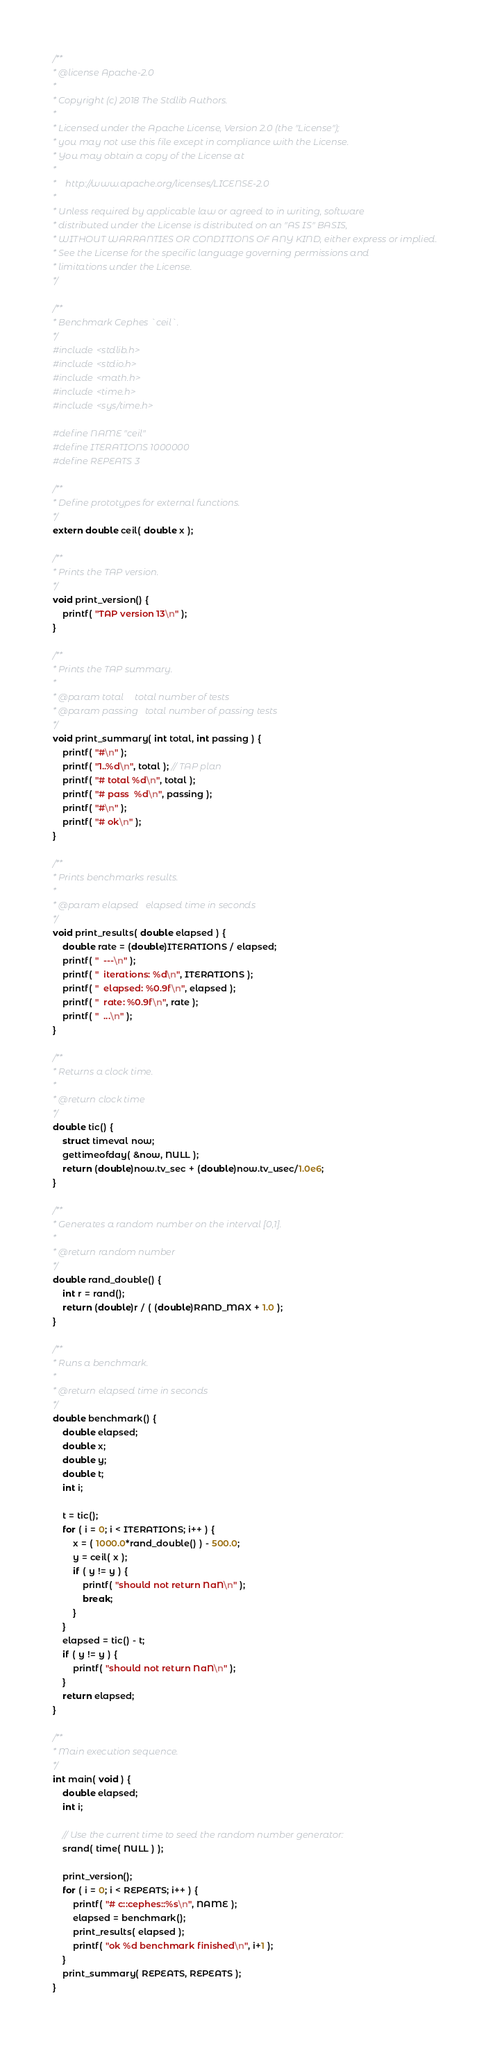Convert code to text. <code><loc_0><loc_0><loc_500><loc_500><_C_>/**
* @license Apache-2.0
*
* Copyright (c) 2018 The Stdlib Authors.
*
* Licensed under the Apache License, Version 2.0 (the "License");
* you may not use this file except in compliance with the License.
* You may obtain a copy of the License at
*
*    http://www.apache.org/licenses/LICENSE-2.0
*
* Unless required by applicable law or agreed to in writing, software
* distributed under the License is distributed on an "AS IS" BASIS,
* WITHOUT WARRANTIES OR CONDITIONS OF ANY KIND, either express or implied.
* See the License for the specific language governing permissions and
* limitations under the License.
*/

/**
* Benchmark Cephes `ceil`.
*/
#include <stdlib.h>
#include <stdio.h>
#include <math.h>
#include <time.h>
#include <sys/time.h>

#define NAME "ceil"
#define ITERATIONS 1000000
#define REPEATS 3

/**
* Define prototypes for external functions.
*/
extern double ceil( double x );

/**
* Prints the TAP version.
*/
void print_version() {
	printf( "TAP version 13\n" );
}

/**
* Prints the TAP summary.
*
* @param total     total number of tests
* @param passing   total number of passing tests
*/
void print_summary( int total, int passing ) {
	printf( "#\n" );
	printf( "1..%d\n", total ); // TAP plan
	printf( "# total %d\n", total );
	printf( "# pass  %d\n", passing );
	printf( "#\n" );
	printf( "# ok\n" );
}

/**
* Prints benchmarks results.
*
* @param elapsed   elapsed time in seconds
*/
void print_results( double elapsed ) {
	double rate = (double)ITERATIONS / elapsed;
	printf( "  ---\n" );
	printf( "  iterations: %d\n", ITERATIONS );
	printf( "  elapsed: %0.9f\n", elapsed );
	printf( "  rate: %0.9f\n", rate );
	printf( "  ...\n" );
}

/**
* Returns a clock time.
*
* @return clock time
*/
double tic() {
	struct timeval now;
	gettimeofday( &now, NULL );
	return (double)now.tv_sec + (double)now.tv_usec/1.0e6;
}

/**
* Generates a random number on the interval [0,1].
*
* @return random number
*/
double rand_double() {
	int r = rand();
	return (double)r / ( (double)RAND_MAX + 1.0 );
}

/**
* Runs a benchmark.
*
* @return elapsed time in seconds
*/
double benchmark() {
	double elapsed;
	double x;
	double y;
	double t;
	int i;

	t = tic();
	for ( i = 0; i < ITERATIONS; i++ ) {
		x = ( 1000.0*rand_double() ) - 500.0;
		y = ceil( x );
		if ( y != y ) {
			printf( "should not return NaN\n" );
			break;
		}
	}
	elapsed = tic() - t;
	if ( y != y ) {
		printf( "should not return NaN\n" );
	}
	return elapsed;
}

/**
* Main execution sequence.
*/
int main( void ) {
	double elapsed;
	int i;

	// Use the current time to seed the random number generator:
	srand( time( NULL ) );

	print_version();
	for ( i = 0; i < REPEATS; i++ ) {
		printf( "# c::cephes::%s\n", NAME );
		elapsed = benchmark();
		print_results( elapsed );
		printf( "ok %d benchmark finished\n", i+1 );
	}
	print_summary( REPEATS, REPEATS );
}
</code> 